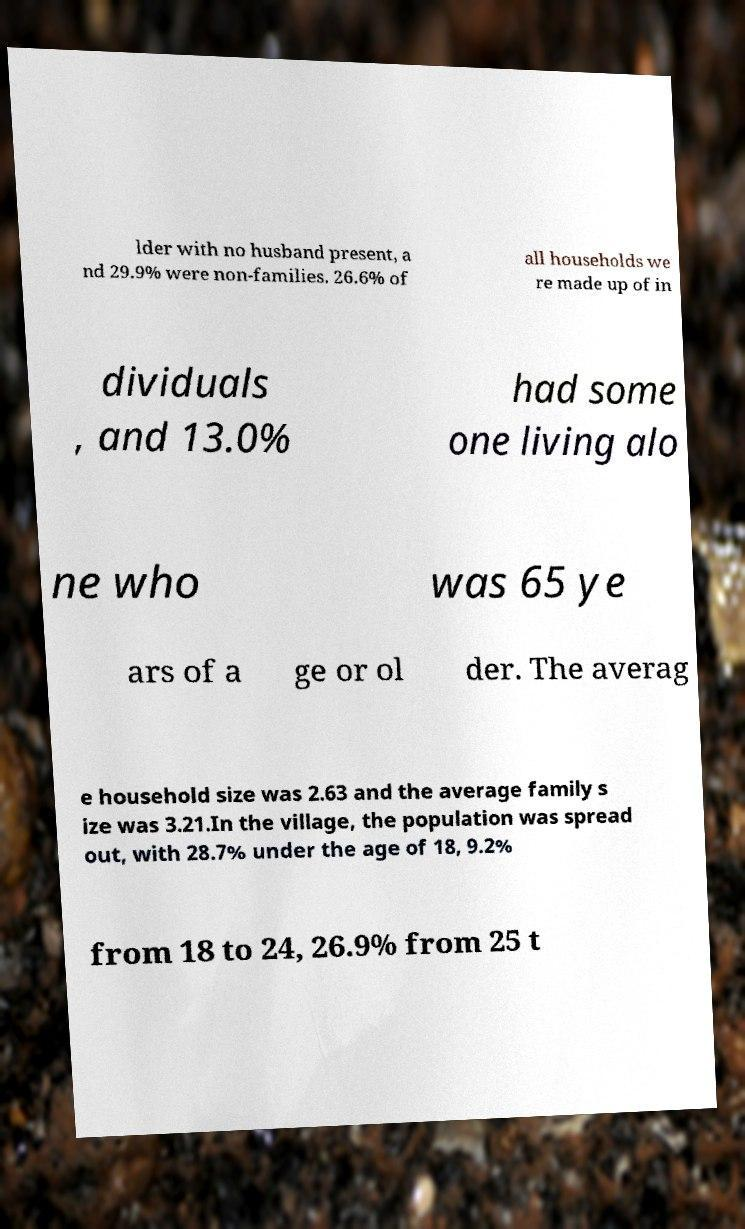What messages or text are displayed in this image? I need them in a readable, typed format. lder with no husband present, a nd 29.9% were non-families. 26.6% of all households we re made up of in dividuals , and 13.0% had some one living alo ne who was 65 ye ars of a ge or ol der. The averag e household size was 2.63 and the average family s ize was 3.21.In the village, the population was spread out, with 28.7% under the age of 18, 9.2% from 18 to 24, 26.9% from 25 t 